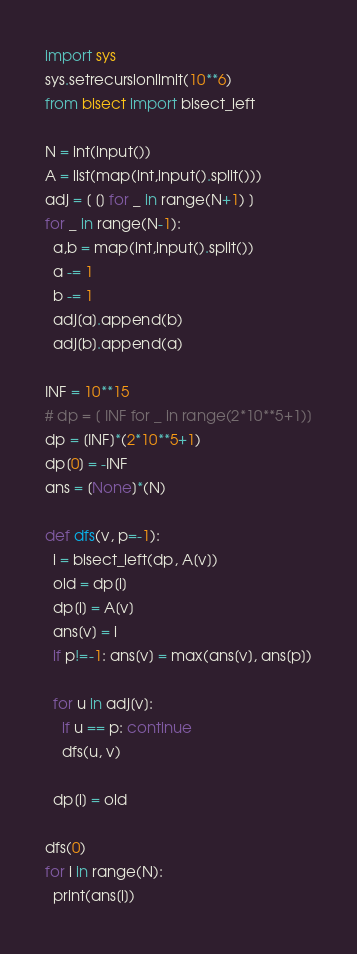<code> <loc_0><loc_0><loc_500><loc_500><_Python_>import sys
sys.setrecursionlimit(10**6)
from bisect import bisect_left
 
N = int(input())
A = list(map(int,input().split()))
adj = [ [] for _ in range(N+1) ]
for _ in range(N-1):
  a,b = map(int,input().split())
  a -= 1
  b -= 1
  adj[a].append(b)
  adj[b].append(a)
 
INF = 10**15
# dp = [ INF for _ in range(2*10**5+1)]
dp = [INF]*(2*10**5+1)
dp[0] = -INF
ans = [None]*(N)
 
def dfs(v, p=-1):
  i = bisect_left(dp, A[v])
  old = dp[i]
  dp[i] = A[v]
  ans[v] = i
  if p!=-1: ans[v] = max(ans[v], ans[p])
 
  for u in adj[v]:
    if u == p: continue
    dfs(u, v)
 
  dp[i] = old
 
dfs(0)
for i in range(N):
  print(ans[i])
</code> 